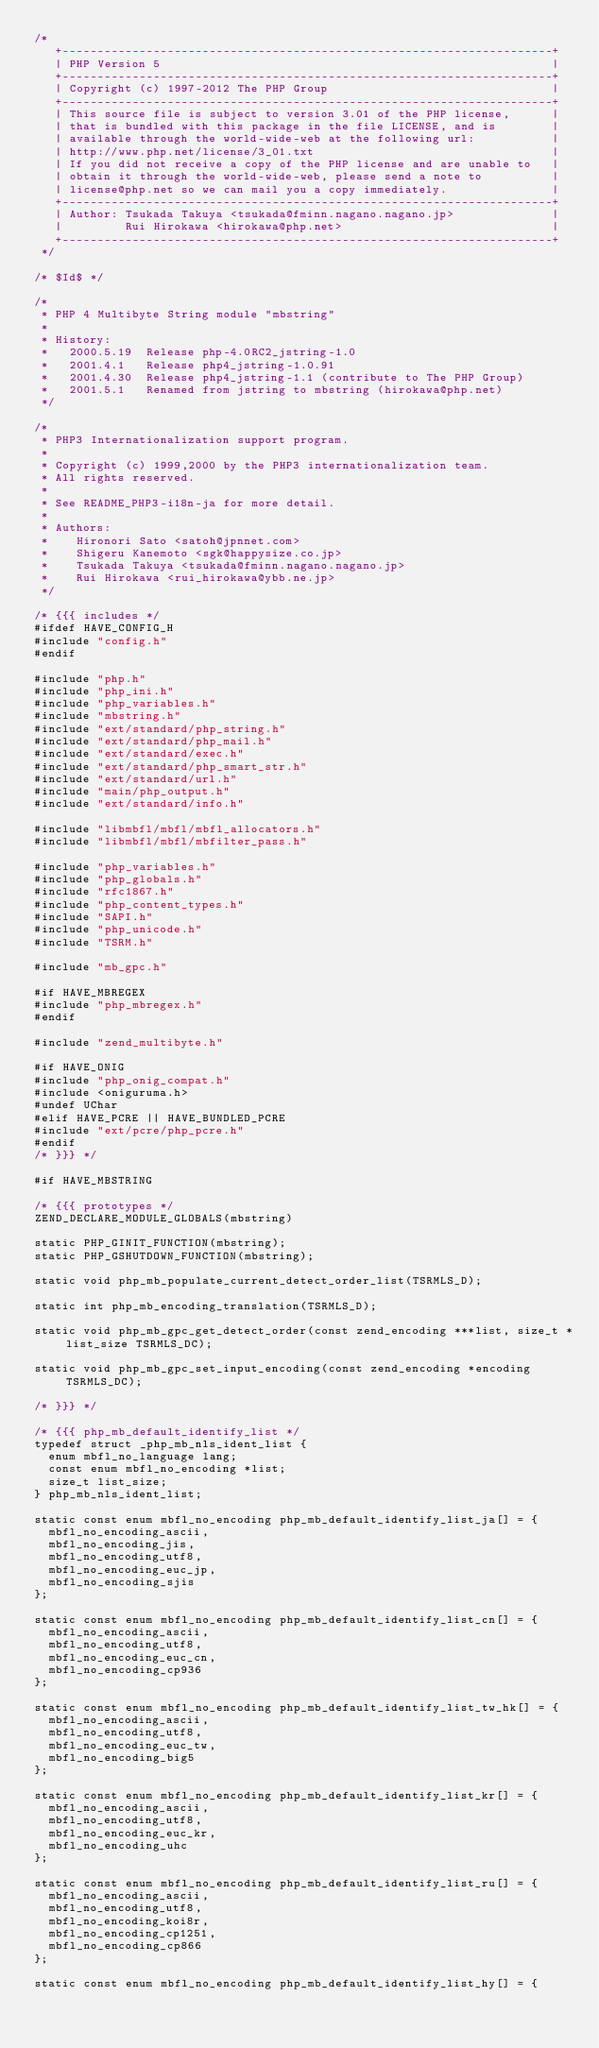<code> <loc_0><loc_0><loc_500><loc_500><_C_>/*
   +----------------------------------------------------------------------+
   | PHP Version 5                                                        |
   +----------------------------------------------------------------------+
   | Copyright (c) 1997-2012 The PHP Group                                |
   +----------------------------------------------------------------------+
   | This source file is subject to version 3.01 of the PHP license,      |
   | that is bundled with this package in the file LICENSE, and is        |
   | available through the world-wide-web at the following url:           |
   | http://www.php.net/license/3_01.txt                                  |
   | If you did not receive a copy of the PHP license and are unable to   |
   | obtain it through the world-wide-web, please send a note to          |
   | license@php.net so we can mail you a copy immediately.               |
   +----------------------------------------------------------------------+
   | Author: Tsukada Takuya <tsukada@fminn.nagano.nagano.jp>              |
   |         Rui Hirokawa <hirokawa@php.net>                              |
   +----------------------------------------------------------------------+
 */

/* $Id$ */

/*
 * PHP 4 Multibyte String module "mbstring"
 *
 * History:
 *   2000.5.19  Release php-4.0RC2_jstring-1.0
 *   2001.4.1   Release php4_jstring-1.0.91
 *   2001.4.30  Release php4_jstring-1.1 (contribute to The PHP Group)
 *   2001.5.1   Renamed from jstring to mbstring (hirokawa@php.net)
 */

/*
 * PHP3 Internationalization support program.
 *
 * Copyright (c) 1999,2000 by the PHP3 internationalization team.
 * All rights reserved.
 *
 * See README_PHP3-i18n-ja for more detail.
 *
 * Authors:
 *    Hironori Sato <satoh@jpnnet.com>
 *    Shigeru Kanemoto <sgk@happysize.co.jp>
 *    Tsukada Takuya <tsukada@fminn.nagano.nagano.jp>
 *    Rui Hirokawa <rui_hirokawa@ybb.ne.jp>
 */

/* {{{ includes */
#ifdef HAVE_CONFIG_H
#include "config.h"
#endif

#include "php.h"
#include "php_ini.h"
#include "php_variables.h"
#include "mbstring.h"
#include "ext/standard/php_string.h"
#include "ext/standard/php_mail.h"
#include "ext/standard/exec.h"
#include "ext/standard/php_smart_str.h"
#include "ext/standard/url.h"
#include "main/php_output.h"
#include "ext/standard/info.h"

#include "libmbfl/mbfl/mbfl_allocators.h"
#include "libmbfl/mbfl/mbfilter_pass.h"

#include "php_variables.h"
#include "php_globals.h"
#include "rfc1867.h"
#include "php_content_types.h"
#include "SAPI.h"
#include "php_unicode.h"
#include "TSRM.h"

#include "mb_gpc.h"

#if HAVE_MBREGEX
#include "php_mbregex.h"
#endif

#include "zend_multibyte.h"

#if HAVE_ONIG
#include "php_onig_compat.h"
#include <oniguruma.h>
#undef UChar
#elif HAVE_PCRE || HAVE_BUNDLED_PCRE
#include "ext/pcre/php_pcre.h"
#endif
/* }}} */

#if HAVE_MBSTRING

/* {{{ prototypes */
ZEND_DECLARE_MODULE_GLOBALS(mbstring)

static PHP_GINIT_FUNCTION(mbstring);
static PHP_GSHUTDOWN_FUNCTION(mbstring);

static void php_mb_populate_current_detect_order_list(TSRMLS_D);

static int php_mb_encoding_translation(TSRMLS_D);

static void php_mb_gpc_get_detect_order(const zend_encoding ***list, size_t *list_size TSRMLS_DC);

static void php_mb_gpc_set_input_encoding(const zend_encoding *encoding TSRMLS_DC);

/* }}} */

/* {{{ php_mb_default_identify_list */
typedef struct _php_mb_nls_ident_list {
	enum mbfl_no_language lang;
	const enum mbfl_no_encoding *list;
	size_t list_size;
} php_mb_nls_ident_list;

static const enum mbfl_no_encoding php_mb_default_identify_list_ja[] = {
	mbfl_no_encoding_ascii,
	mbfl_no_encoding_jis,
	mbfl_no_encoding_utf8,
	mbfl_no_encoding_euc_jp,
	mbfl_no_encoding_sjis
};

static const enum mbfl_no_encoding php_mb_default_identify_list_cn[] = {
	mbfl_no_encoding_ascii,
	mbfl_no_encoding_utf8,
	mbfl_no_encoding_euc_cn,
	mbfl_no_encoding_cp936
};

static const enum mbfl_no_encoding php_mb_default_identify_list_tw_hk[] = {
	mbfl_no_encoding_ascii,
	mbfl_no_encoding_utf8,
	mbfl_no_encoding_euc_tw,
	mbfl_no_encoding_big5
};

static const enum mbfl_no_encoding php_mb_default_identify_list_kr[] = {
	mbfl_no_encoding_ascii,
	mbfl_no_encoding_utf8,
	mbfl_no_encoding_euc_kr,
	mbfl_no_encoding_uhc
};

static const enum mbfl_no_encoding php_mb_default_identify_list_ru[] = {
	mbfl_no_encoding_ascii,
	mbfl_no_encoding_utf8,
	mbfl_no_encoding_koi8r,
	mbfl_no_encoding_cp1251,
	mbfl_no_encoding_cp866
};

static const enum mbfl_no_encoding php_mb_default_identify_list_hy[] = {</code> 